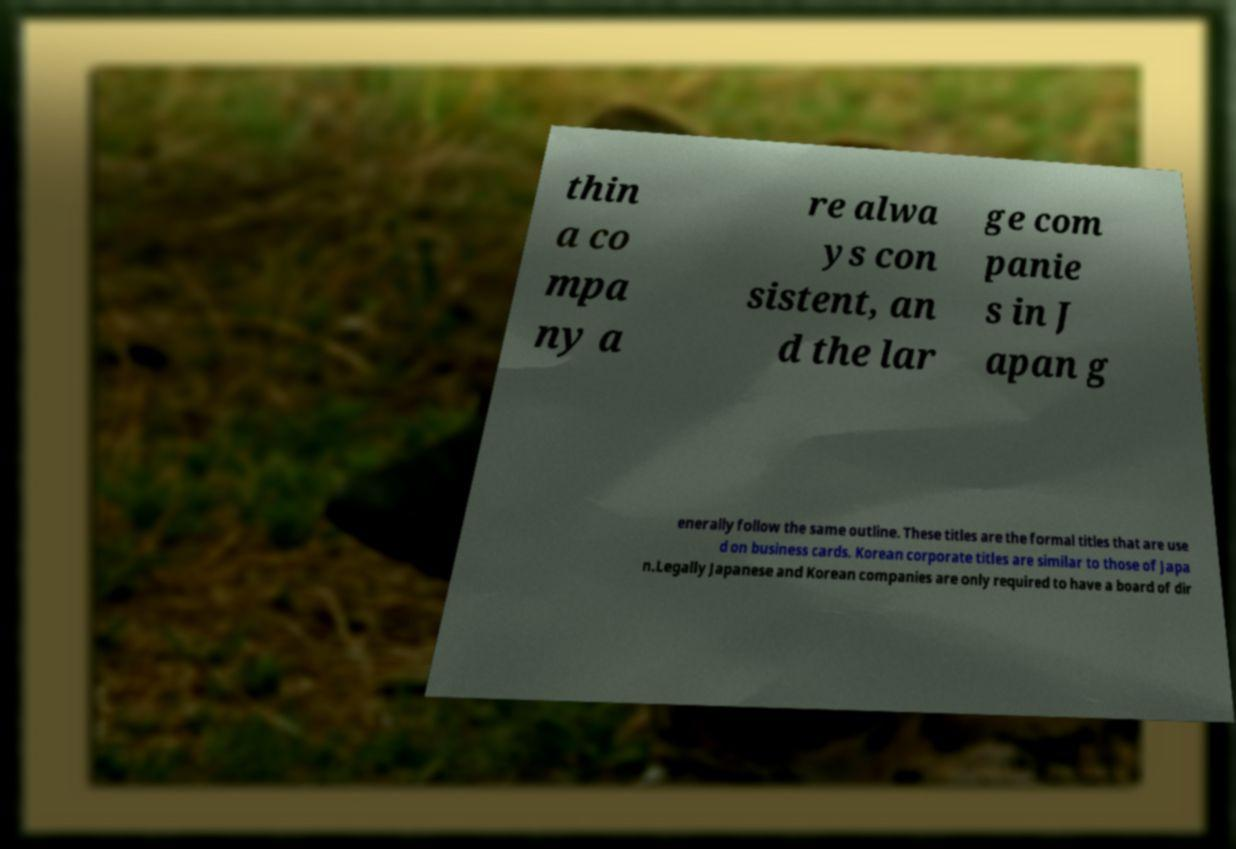Could you assist in decoding the text presented in this image and type it out clearly? thin a co mpa ny a re alwa ys con sistent, an d the lar ge com panie s in J apan g enerally follow the same outline. These titles are the formal titles that are use d on business cards. Korean corporate titles are similar to those of Japa n.Legally Japanese and Korean companies are only required to have a board of dir 